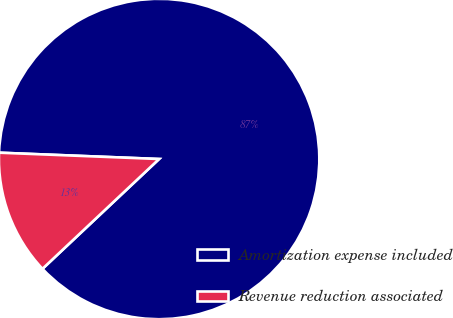Convert chart to OTSL. <chart><loc_0><loc_0><loc_500><loc_500><pie_chart><fcel>Amortization expense included<fcel>Revenue reduction associated<nl><fcel>87.35%<fcel>12.65%<nl></chart> 